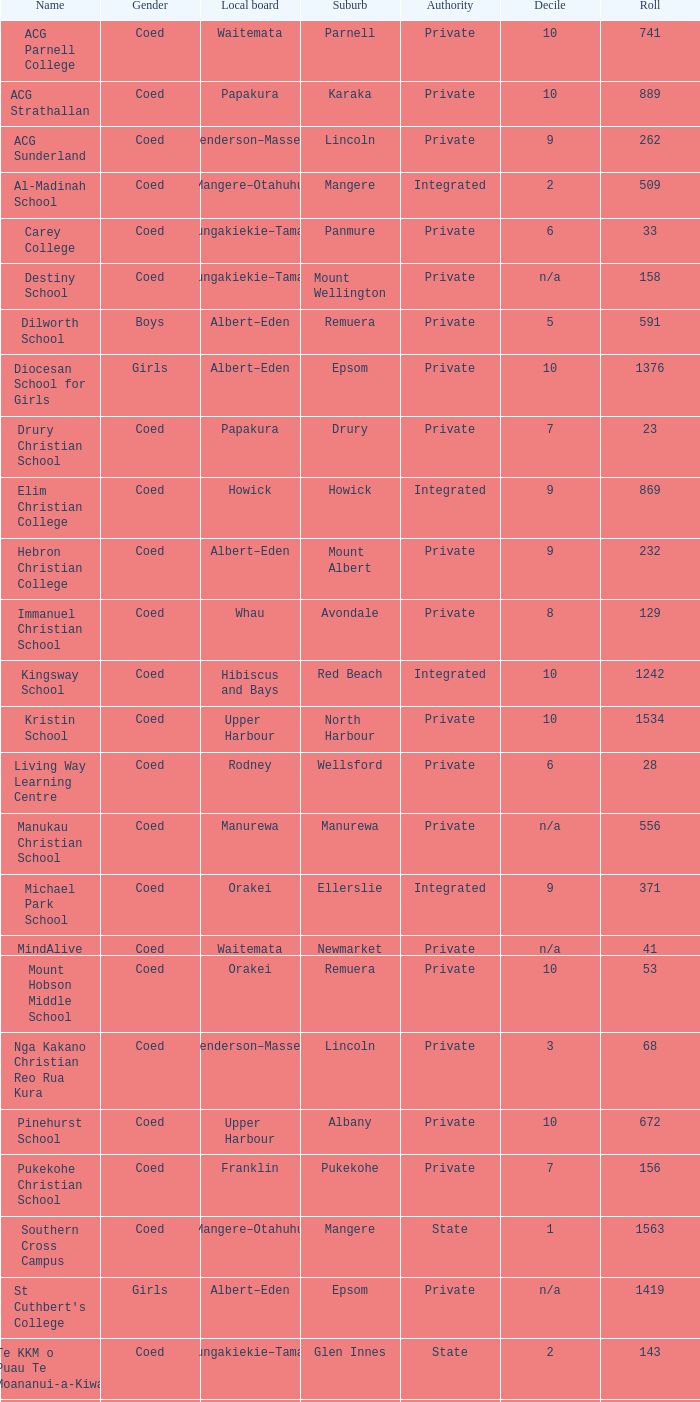What is the name if the local board is albert-eden and has a decile of 9? Hebron Christian College. 